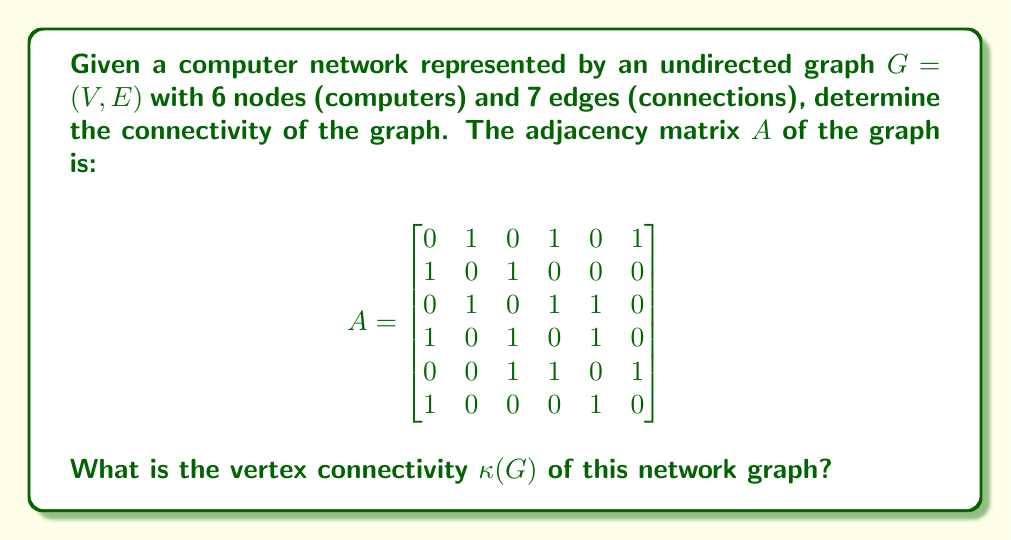Can you answer this question? To determine the vertex connectivity $\kappa(G)$ of the graph, we need to find the minimum number of vertices that need to be removed to disconnect the graph. As an apprentice software engineer, you can think of this as finding the minimum number of computers that, if removed, would break the network into separate components.

Let's approach this step-by-step:

1. First, we need to understand what the adjacency matrix represents. Each 1 in the matrix indicates a connection between two computers.

2. We can visualize the graph using Asymptote:

[asy]
import graph;
size(200);
pair[] g={(-1,0),(0,1),(1,0),(0,-1),(2,-1),(1,1)};
for(int i=0; i<6; ++i) draw(circle(g[i],0.2));
draw(g[0]--g[1]);
draw(g[0]--g[3]);
draw(g[0]--g[5]);
draw(g[1]--g[2]);
draw(g[2]--g[3]);
draw(g[2]--g[4]);
draw(g[3]--g[4]);
draw(g[4]--g[5]);
label("1",g[0],SW);
label("2",g[1],NW);
label("3",g[2],NE);
label("4",g[3],SE);
label("5",g[4],SE);
label("6",g[5],NE);
[/asy]

3. To find $\kappa(G)$, we need to identify the minimum cut set of vertices.

4. Observe that removing nodes 3 and 4 would disconnect the graph into three components: {1,2}, {5}, and {6}.

5. We need to verify if there's a smaller cut set:
   - Removing any single vertex doesn't disconnect the graph.
   - We've found a cut set of size 2, so we need to check if there's another cut set of size 2 that we missed.
   - After checking all pairs, we confirm that {3,4} is the only cut set of size 2.

6. Therefore, the vertex connectivity $\kappa(G)$ is 2.

This means that the network remains connected even if any single computer fails, but it can be disconnected by the failure of two specific computers (nodes 3 and 4).
Answer: The vertex connectivity $\kappa(G)$ of the network graph is 2. 